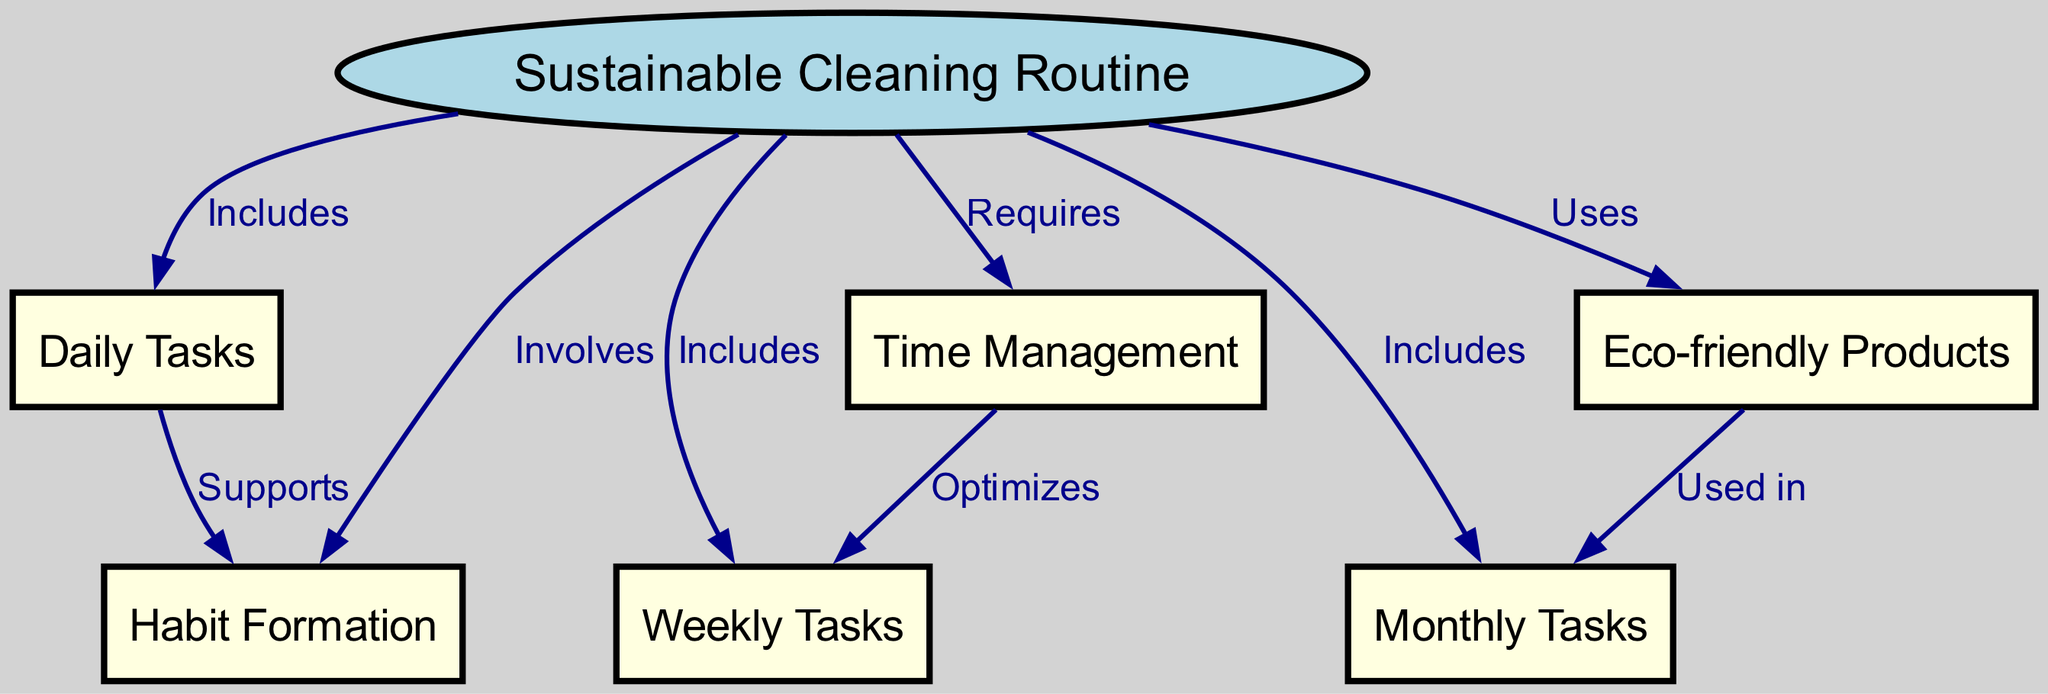What is the main subject of the diagram? The main subject is clearly identified as "Sustainable Cleaning Routine," which is the central node that connects to other related tasks and concepts in the diagram.
Answer: Sustainable Cleaning Routine How many nodes are there in the diagram? By counting the individual nodes listed, we find there are a total of 6 nodes: "Sustainable Cleaning Routine," "Daily Tasks," "Weekly Tasks," "Monthly Tasks," "Eco-friendly Products," and "Time Management."
Answer: 6 What is one of the relationships between "Daily Tasks" and "Habit Formation"? The edge connecting these two nodes shows that "Daily Tasks" supports "Habit Formation," indicating the importance of daily tasks in establishing cleaning habits.
Answer: Supports Which task type is optimized by "Time Management"? The diagram indicates that "Time Management" optimizes "Weekly Tasks," suggesting that proper time management can enhance the efficiency of weekly cleaning activities.
Answer: Weekly Tasks What type of products does the cleaning routine use? The edge labeled "Uses" connecting "Sustainable Cleaning Routine" to "Eco-friendly Products" specifies that eco-friendly products are utilized within the cleaning routine for sustainability.
Answer: Eco-friendly Products Which task is mentioned as being used in conjunction with "Monthly Tasks"? The relationship depicted in the diagram shows that "Eco-friendly Products" are used in "Monthly Tasks," which emphasizes the role of these products in longer-term cleaning efforts.
Answer: Monthly Tasks What is the relationship between "Time Management" and "Weekly Tasks"? The diagram represents that "Time Management" optimizes "Weekly Tasks," meaning effective time management strategies can improve how these tasks are performed.
Answer: Optimizes How does "Daily Tasks" relate to "Habit Formation"? The diagram illustrates that "Daily Tasks" supports "Habit Formation," indicating that performing daily cleaning activities can help in developing and reinforcing cleaning habits over time.
Answer: Supports 